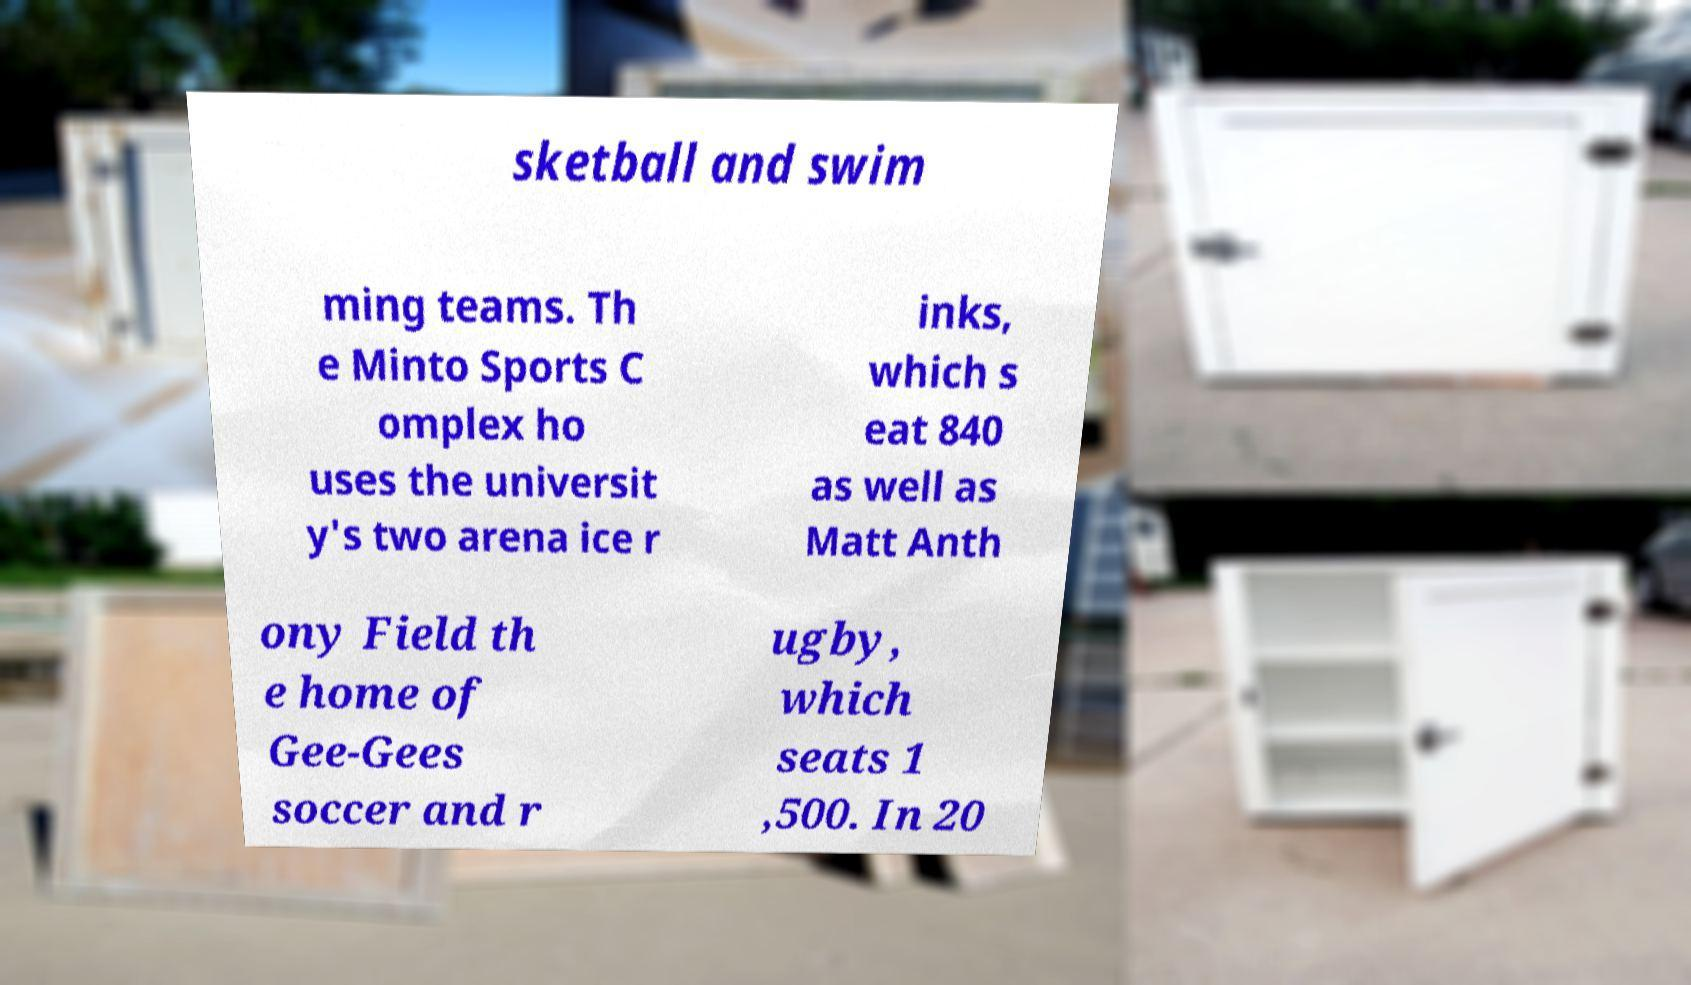Please read and relay the text visible in this image. What does it say? sketball and swim ming teams. Th e Minto Sports C omplex ho uses the universit y's two arena ice r inks, which s eat 840 as well as Matt Anth ony Field th e home of Gee-Gees soccer and r ugby, which seats 1 ,500. In 20 